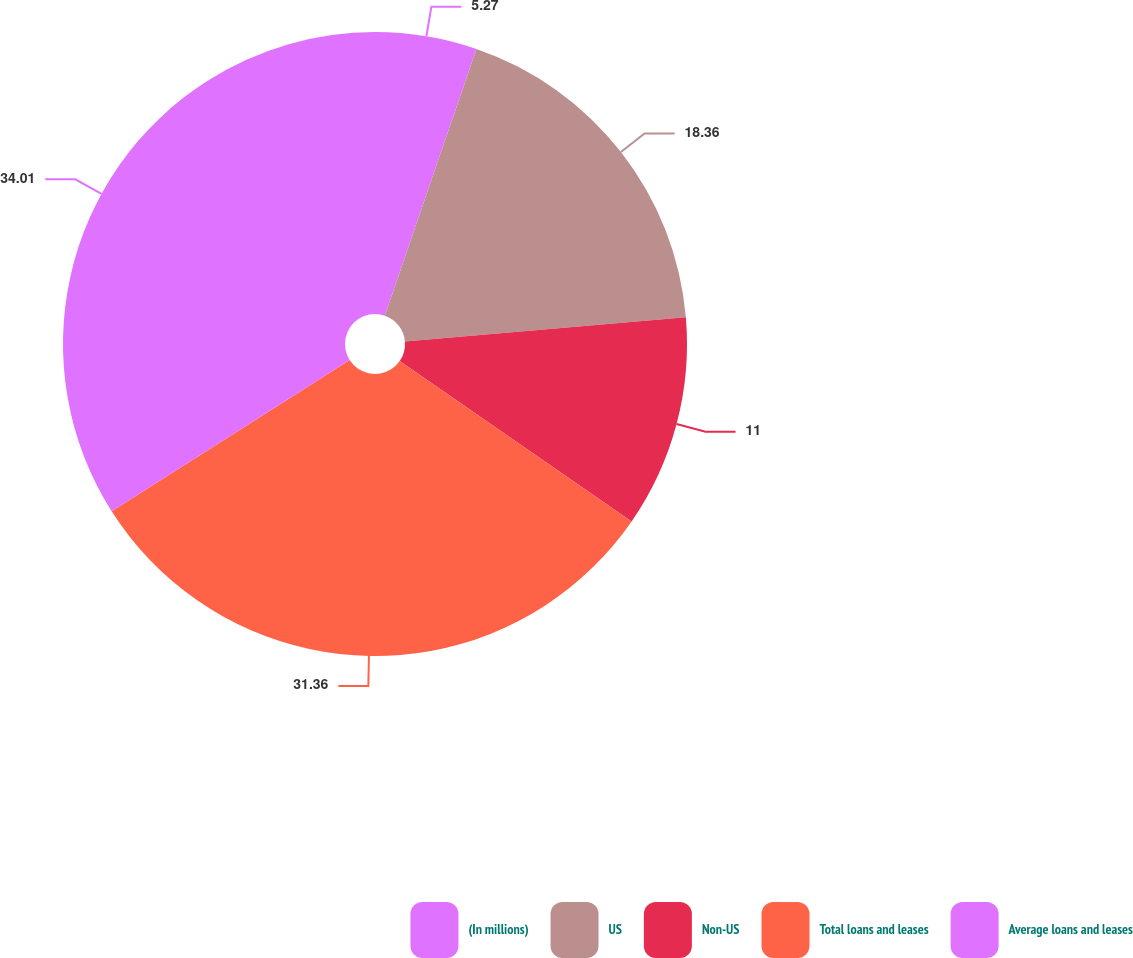Convert chart to OTSL. <chart><loc_0><loc_0><loc_500><loc_500><pie_chart><fcel>(In millions)<fcel>US<fcel>Non-US<fcel>Total loans and leases<fcel>Average loans and leases<nl><fcel>5.27%<fcel>18.36%<fcel>11.0%<fcel>31.36%<fcel>34.01%<nl></chart> 